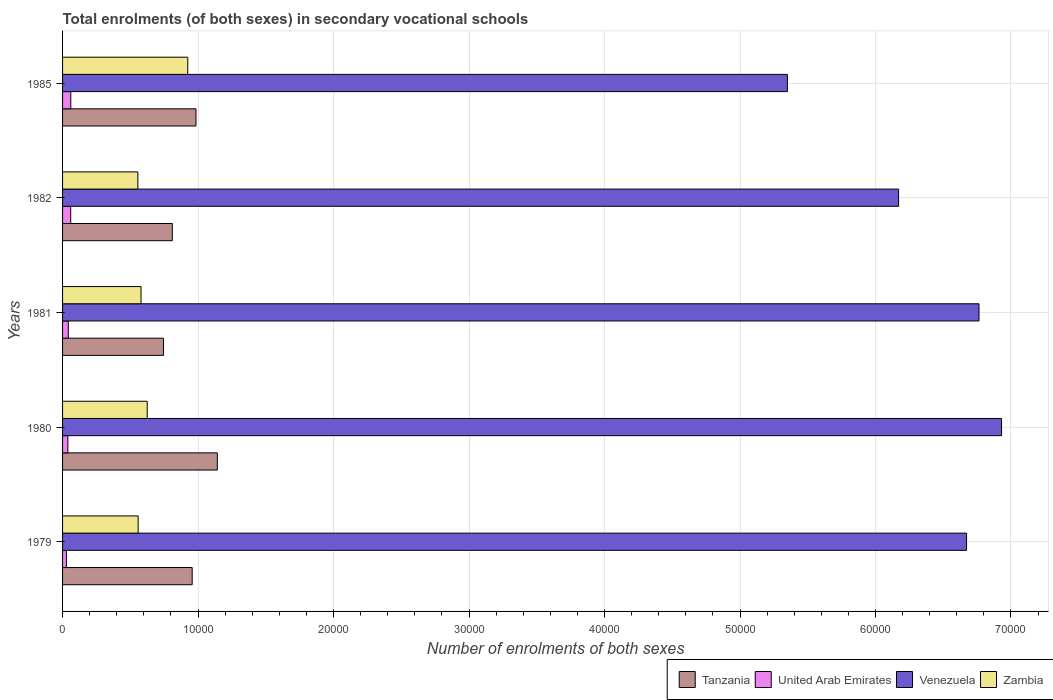How many different coloured bars are there?
Offer a very short reply. 4. How many groups of bars are there?
Make the answer very short. 5. Are the number of bars on each tick of the Y-axis equal?
Provide a short and direct response. Yes. How many bars are there on the 1st tick from the bottom?
Provide a short and direct response. 4. What is the label of the 3rd group of bars from the top?
Your response must be concise. 1981. In how many cases, is the number of bars for a given year not equal to the number of legend labels?
Keep it short and to the point. 0. What is the number of enrolments in secondary schools in Zambia in 1980?
Give a very brief answer. 6248. Across all years, what is the maximum number of enrolments in secondary schools in United Arab Emirates?
Provide a succinct answer. 607. Across all years, what is the minimum number of enrolments in secondary schools in United Arab Emirates?
Ensure brevity in your answer.  284. What is the total number of enrolments in secondary schools in Venezuela in the graph?
Ensure brevity in your answer.  3.19e+05. What is the difference between the number of enrolments in secondary schools in Tanzania in 1979 and that in 1981?
Keep it short and to the point. 2118. What is the difference between the number of enrolments in secondary schools in Zambia in 1981 and the number of enrolments in secondary schools in United Arab Emirates in 1985?
Provide a succinct answer. 5183. What is the average number of enrolments in secondary schools in Tanzania per year?
Keep it short and to the point. 9277.4. In the year 1981, what is the difference between the number of enrolments in secondary schools in Tanzania and number of enrolments in secondary schools in United Arab Emirates?
Your answer should be very brief. 7027. In how many years, is the number of enrolments in secondary schools in Zambia greater than 62000 ?
Offer a terse response. 0. What is the ratio of the number of enrolments in secondary schools in United Arab Emirates in 1980 to that in 1982?
Offer a very short reply. 0.65. Is the number of enrolments in secondary schools in United Arab Emirates in 1980 less than that in 1982?
Provide a short and direct response. Yes. Is the difference between the number of enrolments in secondary schools in Tanzania in 1980 and 1982 greater than the difference between the number of enrolments in secondary schools in United Arab Emirates in 1980 and 1982?
Offer a very short reply. Yes. What is the difference between the highest and the second highest number of enrolments in secondary schools in Venezuela?
Give a very brief answer. 1663. What is the difference between the highest and the lowest number of enrolments in secondary schools in Zambia?
Keep it short and to the point. 3684. What does the 1st bar from the top in 1979 represents?
Keep it short and to the point. Zambia. What does the 4th bar from the bottom in 1980 represents?
Keep it short and to the point. Zambia. What is the difference between two consecutive major ticks on the X-axis?
Your answer should be compact. 10000. Are the values on the major ticks of X-axis written in scientific E-notation?
Provide a succinct answer. No. Does the graph contain any zero values?
Keep it short and to the point. No. Where does the legend appear in the graph?
Provide a short and direct response. Bottom right. What is the title of the graph?
Provide a short and direct response. Total enrolments (of both sexes) in secondary vocational schools. Does "New Caledonia" appear as one of the legend labels in the graph?
Offer a very short reply. No. What is the label or title of the X-axis?
Your response must be concise. Number of enrolments of both sexes. What is the Number of enrolments of both sexes in Tanzania in 1979?
Keep it short and to the point. 9567. What is the Number of enrolments of both sexes of United Arab Emirates in 1979?
Ensure brevity in your answer.  284. What is the Number of enrolments of both sexes in Venezuela in 1979?
Ensure brevity in your answer.  6.67e+04. What is the Number of enrolments of both sexes of Zambia in 1979?
Provide a succinct answer. 5578. What is the Number of enrolments of both sexes in Tanzania in 1980?
Give a very brief answer. 1.14e+04. What is the Number of enrolments of both sexes of United Arab Emirates in 1980?
Keep it short and to the point. 392. What is the Number of enrolments of both sexes in Venezuela in 1980?
Provide a succinct answer. 6.93e+04. What is the Number of enrolments of both sexes in Zambia in 1980?
Your answer should be compact. 6248. What is the Number of enrolments of both sexes in Tanzania in 1981?
Keep it short and to the point. 7449. What is the Number of enrolments of both sexes in United Arab Emirates in 1981?
Your answer should be very brief. 422. What is the Number of enrolments of both sexes of Venezuela in 1981?
Your response must be concise. 6.76e+04. What is the Number of enrolments of both sexes of Zambia in 1981?
Your answer should be very brief. 5790. What is the Number of enrolments of both sexes in Tanzania in 1982?
Provide a succinct answer. 8101. What is the Number of enrolments of both sexes in United Arab Emirates in 1982?
Offer a very short reply. 602. What is the Number of enrolments of both sexes of Venezuela in 1982?
Your response must be concise. 6.17e+04. What is the Number of enrolments of both sexes in Zambia in 1982?
Your answer should be compact. 5557. What is the Number of enrolments of both sexes of Tanzania in 1985?
Your answer should be very brief. 9847. What is the Number of enrolments of both sexes in United Arab Emirates in 1985?
Provide a short and direct response. 607. What is the Number of enrolments of both sexes of Venezuela in 1985?
Ensure brevity in your answer.  5.35e+04. What is the Number of enrolments of both sexes of Zambia in 1985?
Provide a short and direct response. 9241. Across all years, what is the maximum Number of enrolments of both sexes in Tanzania?
Give a very brief answer. 1.14e+04. Across all years, what is the maximum Number of enrolments of both sexes of United Arab Emirates?
Give a very brief answer. 607. Across all years, what is the maximum Number of enrolments of both sexes in Venezuela?
Keep it short and to the point. 6.93e+04. Across all years, what is the maximum Number of enrolments of both sexes of Zambia?
Give a very brief answer. 9241. Across all years, what is the minimum Number of enrolments of both sexes of Tanzania?
Your response must be concise. 7449. Across all years, what is the minimum Number of enrolments of both sexes of United Arab Emirates?
Provide a short and direct response. 284. Across all years, what is the minimum Number of enrolments of both sexes of Venezuela?
Give a very brief answer. 5.35e+04. Across all years, what is the minimum Number of enrolments of both sexes in Zambia?
Ensure brevity in your answer.  5557. What is the total Number of enrolments of both sexes in Tanzania in the graph?
Give a very brief answer. 4.64e+04. What is the total Number of enrolments of both sexes in United Arab Emirates in the graph?
Offer a very short reply. 2307. What is the total Number of enrolments of both sexes of Venezuela in the graph?
Provide a succinct answer. 3.19e+05. What is the total Number of enrolments of both sexes in Zambia in the graph?
Offer a terse response. 3.24e+04. What is the difference between the Number of enrolments of both sexes of Tanzania in 1979 and that in 1980?
Ensure brevity in your answer.  -1856. What is the difference between the Number of enrolments of both sexes of United Arab Emirates in 1979 and that in 1980?
Your response must be concise. -108. What is the difference between the Number of enrolments of both sexes of Venezuela in 1979 and that in 1980?
Provide a short and direct response. -2582. What is the difference between the Number of enrolments of both sexes of Zambia in 1979 and that in 1980?
Ensure brevity in your answer.  -670. What is the difference between the Number of enrolments of both sexes in Tanzania in 1979 and that in 1981?
Your response must be concise. 2118. What is the difference between the Number of enrolments of both sexes of United Arab Emirates in 1979 and that in 1981?
Keep it short and to the point. -138. What is the difference between the Number of enrolments of both sexes of Venezuela in 1979 and that in 1981?
Ensure brevity in your answer.  -919. What is the difference between the Number of enrolments of both sexes of Zambia in 1979 and that in 1981?
Your answer should be compact. -212. What is the difference between the Number of enrolments of both sexes in Tanzania in 1979 and that in 1982?
Your response must be concise. 1466. What is the difference between the Number of enrolments of both sexes in United Arab Emirates in 1979 and that in 1982?
Provide a short and direct response. -318. What is the difference between the Number of enrolments of both sexes of Venezuela in 1979 and that in 1982?
Your answer should be compact. 5016. What is the difference between the Number of enrolments of both sexes in Tanzania in 1979 and that in 1985?
Offer a very short reply. -280. What is the difference between the Number of enrolments of both sexes in United Arab Emirates in 1979 and that in 1985?
Give a very brief answer. -323. What is the difference between the Number of enrolments of both sexes in Venezuela in 1979 and that in 1985?
Your response must be concise. 1.32e+04. What is the difference between the Number of enrolments of both sexes of Zambia in 1979 and that in 1985?
Provide a succinct answer. -3663. What is the difference between the Number of enrolments of both sexes in Tanzania in 1980 and that in 1981?
Offer a very short reply. 3974. What is the difference between the Number of enrolments of both sexes in United Arab Emirates in 1980 and that in 1981?
Provide a succinct answer. -30. What is the difference between the Number of enrolments of both sexes of Venezuela in 1980 and that in 1981?
Provide a succinct answer. 1663. What is the difference between the Number of enrolments of both sexes of Zambia in 1980 and that in 1981?
Offer a terse response. 458. What is the difference between the Number of enrolments of both sexes of Tanzania in 1980 and that in 1982?
Offer a very short reply. 3322. What is the difference between the Number of enrolments of both sexes of United Arab Emirates in 1980 and that in 1982?
Provide a succinct answer. -210. What is the difference between the Number of enrolments of both sexes of Venezuela in 1980 and that in 1982?
Keep it short and to the point. 7598. What is the difference between the Number of enrolments of both sexes in Zambia in 1980 and that in 1982?
Give a very brief answer. 691. What is the difference between the Number of enrolments of both sexes in Tanzania in 1980 and that in 1985?
Make the answer very short. 1576. What is the difference between the Number of enrolments of both sexes in United Arab Emirates in 1980 and that in 1985?
Your answer should be very brief. -215. What is the difference between the Number of enrolments of both sexes of Venezuela in 1980 and that in 1985?
Your answer should be compact. 1.58e+04. What is the difference between the Number of enrolments of both sexes in Zambia in 1980 and that in 1985?
Your answer should be compact. -2993. What is the difference between the Number of enrolments of both sexes of Tanzania in 1981 and that in 1982?
Your answer should be compact. -652. What is the difference between the Number of enrolments of both sexes of United Arab Emirates in 1981 and that in 1982?
Your answer should be compact. -180. What is the difference between the Number of enrolments of both sexes of Venezuela in 1981 and that in 1982?
Your answer should be compact. 5935. What is the difference between the Number of enrolments of both sexes in Zambia in 1981 and that in 1982?
Make the answer very short. 233. What is the difference between the Number of enrolments of both sexes of Tanzania in 1981 and that in 1985?
Provide a short and direct response. -2398. What is the difference between the Number of enrolments of both sexes of United Arab Emirates in 1981 and that in 1985?
Offer a terse response. -185. What is the difference between the Number of enrolments of both sexes of Venezuela in 1981 and that in 1985?
Ensure brevity in your answer.  1.41e+04. What is the difference between the Number of enrolments of both sexes of Zambia in 1981 and that in 1985?
Offer a terse response. -3451. What is the difference between the Number of enrolments of both sexes of Tanzania in 1982 and that in 1985?
Your answer should be very brief. -1746. What is the difference between the Number of enrolments of both sexes in United Arab Emirates in 1982 and that in 1985?
Give a very brief answer. -5. What is the difference between the Number of enrolments of both sexes of Venezuela in 1982 and that in 1985?
Keep it short and to the point. 8209. What is the difference between the Number of enrolments of both sexes of Zambia in 1982 and that in 1985?
Your answer should be very brief. -3684. What is the difference between the Number of enrolments of both sexes of Tanzania in 1979 and the Number of enrolments of both sexes of United Arab Emirates in 1980?
Keep it short and to the point. 9175. What is the difference between the Number of enrolments of both sexes of Tanzania in 1979 and the Number of enrolments of both sexes of Venezuela in 1980?
Offer a terse response. -5.97e+04. What is the difference between the Number of enrolments of both sexes in Tanzania in 1979 and the Number of enrolments of both sexes in Zambia in 1980?
Provide a succinct answer. 3319. What is the difference between the Number of enrolments of both sexes of United Arab Emirates in 1979 and the Number of enrolments of both sexes of Venezuela in 1980?
Your answer should be very brief. -6.90e+04. What is the difference between the Number of enrolments of both sexes of United Arab Emirates in 1979 and the Number of enrolments of both sexes of Zambia in 1980?
Your response must be concise. -5964. What is the difference between the Number of enrolments of both sexes in Venezuela in 1979 and the Number of enrolments of both sexes in Zambia in 1980?
Your answer should be very brief. 6.05e+04. What is the difference between the Number of enrolments of both sexes of Tanzania in 1979 and the Number of enrolments of both sexes of United Arab Emirates in 1981?
Your answer should be very brief. 9145. What is the difference between the Number of enrolments of both sexes in Tanzania in 1979 and the Number of enrolments of both sexes in Venezuela in 1981?
Ensure brevity in your answer.  -5.81e+04. What is the difference between the Number of enrolments of both sexes of Tanzania in 1979 and the Number of enrolments of both sexes of Zambia in 1981?
Your response must be concise. 3777. What is the difference between the Number of enrolments of both sexes of United Arab Emirates in 1979 and the Number of enrolments of both sexes of Venezuela in 1981?
Your response must be concise. -6.74e+04. What is the difference between the Number of enrolments of both sexes in United Arab Emirates in 1979 and the Number of enrolments of both sexes in Zambia in 1981?
Provide a short and direct response. -5506. What is the difference between the Number of enrolments of both sexes in Venezuela in 1979 and the Number of enrolments of both sexes in Zambia in 1981?
Offer a very short reply. 6.09e+04. What is the difference between the Number of enrolments of both sexes in Tanzania in 1979 and the Number of enrolments of both sexes in United Arab Emirates in 1982?
Your answer should be compact. 8965. What is the difference between the Number of enrolments of both sexes in Tanzania in 1979 and the Number of enrolments of both sexes in Venezuela in 1982?
Your response must be concise. -5.21e+04. What is the difference between the Number of enrolments of both sexes of Tanzania in 1979 and the Number of enrolments of both sexes of Zambia in 1982?
Make the answer very short. 4010. What is the difference between the Number of enrolments of both sexes in United Arab Emirates in 1979 and the Number of enrolments of both sexes in Venezuela in 1982?
Provide a short and direct response. -6.14e+04. What is the difference between the Number of enrolments of both sexes of United Arab Emirates in 1979 and the Number of enrolments of both sexes of Zambia in 1982?
Your answer should be very brief. -5273. What is the difference between the Number of enrolments of both sexes of Venezuela in 1979 and the Number of enrolments of both sexes of Zambia in 1982?
Your answer should be compact. 6.12e+04. What is the difference between the Number of enrolments of both sexes in Tanzania in 1979 and the Number of enrolments of both sexes in United Arab Emirates in 1985?
Your answer should be compact. 8960. What is the difference between the Number of enrolments of both sexes in Tanzania in 1979 and the Number of enrolments of both sexes in Venezuela in 1985?
Ensure brevity in your answer.  -4.39e+04. What is the difference between the Number of enrolments of both sexes in Tanzania in 1979 and the Number of enrolments of both sexes in Zambia in 1985?
Offer a very short reply. 326. What is the difference between the Number of enrolments of both sexes of United Arab Emirates in 1979 and the Number of enrolments of both sexes of Venezuela in 1985?
Provide a short and direct response. -5.32e+04. What is the difference between the Number of enrolments of both sexes in United Arab Emirates in 1979 and the Number of enrolments of both sexes in Zambia in 1985?
Ensure brevity in your answer.  -8957. What is the difference between the Number of enrolments of both sexes of Venezuela in 1979 and the Number of enrolments of both sexes of Zambia in 1985?
Your answer should be very brief. 5.75e+04. What is the difference between the Number of enrolments of both sexes in Tanzania in 1980 and the Number of enrolments of both sexes in United Arab Emirates in 1981?
Your answer should be compact. 1.10e+04. What is the difference between the Number of enrolments of both sexes of Tanzania in 1980 and the Number of enrolments of both sexes of Venezuela in 1981?
Your answer should be very brief. -5.62e+04. What is the difference between the Number of enrolments of both sexes in Tanzania in 1980 and the Number of enrolments of both sexes in Zambia in 1981?
Provide a succinct answer. 5633. What is the difference between the Number of enrolments of both sexes of United Arab Emirates in 1980 and the Number of enrolments of both sexes of Venezuela in 1981?
Your answer should be very brief. -6.72e+04. What is the difference between the Number of enrolments of both sexes in United Arab Emirates in 1980 and the Number of enrolments of both sexes in Zambia in 1981?
Offer a very short reply. -5398. What is the difference between the Number of enrolments of both sexes of Venezuela in 1980 and the Number of enrolments of both sexes of Zambia in 1981?
Your answer should be compact. 6.35e+04. What is the difference between the Number of enrolments of both sexes of Tanzania in 1980 and the Number of enrolments of both sexes of United Arab Emirates in 1982?
Offer a very short reply. 1.08e+04. What is the difference between the Number of enrolments of both sexes of Tanzania in 1980 and the Number of enrolments of both sexes of Venezuela in 1982?
Offer a very short reply. -5.03e+04. What is the difference between the Number of enrolments of both sexes in Tanzania in 1980 and the Number of enrolments of both sexes in Zambia in 1982?
Keep it short and to the point. 5866. What is the difference between the Number of enrolments of both sexes of United Arab Emirates in 1980 and the Number of enrolments of both sexes of Venezuela in 1982?
Keep it short and to the point. -6.13e+04. What is the difference between the Number of enrolments of both sexes in United Arab Emirates in 1980 and the Number of enrolments of both sexes in Zambia in 1982?
Offer a very short reply. -5165. What is the difference between the Number of enrolments of both sexes of Venezuela in 1980 and the Number of enrolments of both sexes of Zambia in 1982?
Make the answer very short. 6.37e+04. What is the difference between the Number of enrolments of both sexes in Tanzania in 1980 and the Number of enrolments of both sexes in United Arab Emirates in 1985?
Provide a succinct answer. 1.08e+04. What is the difference between the Number of enrolments of both sexes of Tanzania in 1980 and the Number of enrolments of both sexes of Venezuela in 1985?
Your response must be concise. -4.21e+04. What is the difference between the Number of enrolments of both sexes in Tanzania in 1980 and the Number of enrolments of both sexes in Zambia in 1985?
Your answer should be compact. 2182. What is the difference between the Number of enrolments of both sexes of United Arab Emirates in 1980 and the Number of enrolments of both sexes of Venezuela in 1985?
Ensure brevity in your answer.  -5.31e+04. What is the difference between the Number of enrolments of both sexes in United Arab Emirates in 1980 and the Number of enrolments of both sexes in Zambia in 1985?
Offer a very short reply. -8849. What is the difference between the Number of enrolments of both sexes in Venezuela in 1980 and the Number of enrolments of both sexes in Zambia in 1985?
Provide a short and direct response. 6.01e+04. What is the difference between the Number of enrolments of both sexes of Tanzania in 1981 and the Number of enrolments of both sexes of United Arab Emirates in 1982?
Your answer should be compact. 6847. What is the difference between the Number of enrolments of both sexes in Tanzania in 1981 and the Number of enrolments of both sexes in Venezuela in 1982?
Provide a succinct answer. -5.43e+04. What is the difference between the Number of enrolments of both sexes of Tanzania in 1981 and the Number of enrolments of both sexes of Zambia in 1982?
Provide a short and direct response. 1892. What is the difference between the Number of enrolments of both sexes of United Arab Emirates in 1981 and the Number of enrolments of both sexes of Venezuela in 1982?
Your response must be concise. -6.13e+04. What is the difference between the Number of enrolments of both sexes of United Arab Emirates in 1981 and the Number of enrolments of both sexes of Zambia in 1982?
Your response must be concise. -5135. What is the difference between the Number of enrolments of both sexes in Venezuela in 1981 and the Number of enrolments of both sexes in Zambia in 1982?
Your answer should be very brief. 6.21e+04. What is the difference between the Number of enrolments of both sexes of Tanzania in 1981 and the Number of enrolments of both sexes of United Arab Emirates in 1985?
Offer a very short reply. 6842. What is the difference between the Number of enrolments of both sexes of Tanzania in 1981 and the Number of enrolments of both sexes of Venezuela in 1985?
Provide a short and direct response. -4.60e+04. What is the difference between the Number of enrolments of both sexes of Tanzania in 1981 and the Number of enrolments of both sexes of Zambia in 1985?
Give a very brief answer. -1792. What is the difference between the Number of enrolments of both sexes in United Arab Emirates in 1981 and the Number of enrolments of both sexes in Venezuela in 1985?
Provide a short and direct response. -5.31e+04. What is the difference between the Number of enrolments of both sexes in United Arab Emirates in 1981 and the Number of enrolments of both sexes in Zambia in 1985?
Your answer should be very brief. -8819. What is the difference between the Number of enrolments of both sexes of Venezuela in 1981 and the Number of enrolments of both sexes of Zambia in 1985?
Ensure brevity in your answer.  5.84e+04. What is the difference between the Number of enrolments of both sexes of Tanzania in 1982 and the Number of enrolments of both sexes of United Arab Emirates in 1985?
Ensure brevity in your answer.  7494. What is the difference between the Number of enrolments of both sexes of Tanzania in 1982 and the Number of enrolments of both sexes of Venezuela in 1985?
Make the answer very short. -4.54e+04. What is the difference between the Number of enrolments of both sexes in Tanzania in 1982 and the Number of enrolments of both sexes in Zambia in 1985?
Provide a succinct answer. -1140. What is the difference between the Number of enrolments of both sexes in United Arab Emirates in 1982 and the Number of enrolments of both sexes in Venezuela in 1985?
Make the answer very short. -5.29e+04. What is the difference between the Number of enrolments of both sexes in United Arab Emirates in 1982 and the Number of enrolments of both sexes in Zambia in 1985?
Your response must be concise. -8639. What is the difference between the Number of enrolments of both sexes of Venezuela in 1982 and the Number of enrolments of both sexes of Zambia in 1985?
Offer a terse response. 5.25e+04. What is the average Number of enrolments of both sexes in Tanzania per year?
Your response must be concise. 9277.4. What is the average Number of enrolments of both sexes in United Arab Emirates per year?
Your response must be concise. 461.4. What is the average Number of enrolments of both sexes of Venezuela per year?
Your response must be concise. 6.38e+04. What is the average Number of enrolments of both sexes of Zambia per year?
Your answer should be compact. 6482.8. In the year 1979, what is the difference between the Number of enrolments of both sexes in Tanzania and Number of enrolments of both sexes in United Arab Emirates?
Make the answer very short. 9283. In the year 1979, what is the difference between the Number of enrolments of both sexes in Tanzania and Number of enrolments of both sexes in Venezuela?
Keep it short and to the point. -5.72e+04. In the year 1979, what is the difference between the Number of enrolments of both sexes of Tanzania and Number of enrolments of both sexes of Zambia?
Make the answer very short. 3989. In the year 1979, what is the difference between the Number of enrolments of both sexes of United Arab Emirates and Number of enrolments of both sexes of Venezuela?
Make the answer very short. -6.64e+04. In the year 1979, what is the difference between the Number of enrolments of both sexes of United Arab Emirates and Number of enrolments of both sexes of Zambia?
Provide a succinct answer. -5294. In the year 1979, what is the difference between the Number of enrolments of both sexes of Venezuela and Number of enrolments of both sexes of Zambia?
Your answer should be very brief. 6.11e+04. In the year 1980, what is the difference between the Number of enrolments of both sexes in Tanzania and Number of enrolments of both sexes in United Arab Emirates?
Ensure brevity in your answer.  1.10e+04. In the year 1980, what is the difference between the Number of enrolments of both sexes in Tanzania and Number of enrolments of both sexes in Venezuela?
Your answer should be very brief. -5.79e+04. In the year 1980, what is the difference between the Number of enrolments of both sexes in Tanzania and Number of enrolments of both sexes in Zambia?
Offer a terse response. 5175. In the year 1980, what is the difference between the Number of enrolments of both sexes in United Arab Emirates and Number of enrolments of both sexes in Venezuela?
Ensure brevity in your answer.  -6.89e+04. In the year 1980, what is the difference between the Number of enrolments of both sexes of United Arab Emirates and Number of enrolments of both sexes of Zambia?
Your response must be concise. -5856. In the year 1980, what is the difference between the Number of enrolments of both sexes in Venezuela and Number of enrolments of both sexes in Zambia?
Keep it short and to the point. 6.31e+04. In the year 1981, what is the difference between the Number of enrolments of both sexes of Tanzania and Number of enrolments of both sexes of United Arab Emirates?
Give a very brief answer. 7027. In the year 1981, what is the difference between the Number of enrolments of both sexes of Tanzania and Number of enrolments of both sexes of Venezuela?
Make the answer very short. -6.02e+04. In the year 1981, what is the difference between the Number of enrolments of both sexes in Tanzania and Number of enrolments of both sexes in Zambia?
Your answer should be compact. 1659. In the year 1981, what is the difference between the Number of enrolments of both sexes in United Arab Emirates and Number of enrolments of both sexes in Venezuela?
Make the answer very short. -6.72e+04. In the year 1981, what is the difference between the Number of enrolments of both sexes of United Arab Emirates and Number of enrolments of both sexes of Zambia?
Your response must be concise. -5368. In the year 1981, what is the difference between the Number of enrolments of both sexes of Venezuela and Number of enrolments of both sexes of Zambia?
Ensure brevity in your answer.  6.19e+04. In the year 1982, what is the difference between the Number of enrolments of both sexes in Tanzania and Number of enrolments of both sexes in United Arab Emirates?
Provide a short and direct response. 7499. In the year 1982, what is the difference between the Number of enrolments of both sexes of Tanzania and Number of enrolments of both sexes of Venezuela?
Give a very brief answer. -5.36e+04. In the year 1982, what is the difference between the Number of enrolments of both sexes in Tanzania and Number of enrolments of both sexes in Zambia?
Give a very brief answer. 2544. In the year 1982, what is the difference between the Number of enrolments of both sexes in United Arab Emirates and Number of enrolments of both sexes in Venezuela?
Your answer should be very brief. -6.11e+04. In the year 1982, what is the difference between the Number of enrolments of both sexes of United Arab Emirates and Number of enrolments of both sexes of Zambia?
Ensure brevity in your answer.  -4955. In the year 1982, what is the difference between the Number of enrolments of both sexes of Venezuela and Number of enrolments of both sexes of Zambia?
Keep it short and to the point. 5.61e+04. In the year 1985, what is the difference between the Number of enrolments of both sexes in Tanzania and Number of enrolments of both sexes in United Arab Emirates?
Give a very brief answer. 9240. In the year 1985, what is the difference between the Number of enrolments of both sexes in Tanzania and Number of enrolments of both sexes in Venezuela?
Your response must be concise. -4.36e+04. In the year 1985, what is the difference between the Number of enrolments of both sexes in Tanzania and Number of enrolments of both sexes in Zambia?
Offer a very short reply. 606. In the year 1985, what is the difference between the Number of enrolments of both sexes in United Arab Emirates and Number of enrolments of both sexes in Venezuela?
Make the answer very short. -5.29e+04. In the year 1985, what is the difference between the Number of enrolments of both sexes of United Arab Emirates and Number of enrolments of both sexes of Zambia?
Give a very brief answer. -8634. In the year 1985, what is the difference between the Number of enrolments of both sexes in Venezuela and Number of enrolments of both sexes in Zambia?
Your answer should be very brief. 4.43e+04. What is the ratio of the Number of enrolments of both sexes in Tanzania in 1979 to that in 1980?
Offer a very short reply. 0.84. What is the ratio of the Number of enrolments of both sexes in United Arab Emirates in 1979 to that in 1980?
Your answer should be compact. 0.72. What is the ratio of the Number of enrolments of both sexes of Venezuela in 1979 to that in 1980?
Your answer should be compact. 0.96. What is the ratio of the Number of enrolments of both sexes of Zambia in 1979 to that in 1980?
Give a very brief answer. 0.89. What is the ratio of the Number of enrolments of both sexes of Tanzania in 1979 to that in 1981?
Your response must be concise. 1.28. What is the ratio of the Number of enrolments of both sexes of United Arab Emirates in 1979 to that in 1981?
Your response must be concise. 0.67. What is the ratio of the Number of enrolments of both sexes of Venezuela in 1979 to that in 1981?
Provide a succinct answer. 0.99. What is the ratio of the Number of enrolments of both sexes of Zambia in 1979 to that in 1981?
Provide a succinct answer. 0.96. What is the ratio of the Number of enrolments of both sexes of Tanzania in 1979 to that in 1982?
Ensure brevity in your answer.  1.18. What is the ratio of the Number of enrolments of both sexes in United Arab Emirates in 1979 to that in 1982?
Offer a very short reply. 0.47. What is the ratio of the Number of enrolments of both sexes in Venezuela in 1979 to that in 1982?
Provide a short and direct response. 1.08. What is the ratio of the Number of enrolments of both sexes in Tanzania in 1979 to that in 1985?
Ensure brevity in your answer.  0.97. What is the ratio of the Number of enrolments of both sexes of United Arab Emirates in 1979 to that in 1985?
Your response must be concise. 0.47. What is the ratio of the Number of enrolments of both sexes of Venezuela in 1979 to that in 1985?
Provide a short and direct response. 1.25. What is the ratio of the Number of enrolments of both sexes in Zambia in 1979 to that in 1985?
Your response must be concise. 0.6. What is the ratio of the Number of enrolments of both sexes of Tanzania in 1980 to that in 1981?
Keep it short and to the point. 1.53. What is the ratio of the Number of enrolments of both sexes of United Arab Emirates in 1980 to that in 1981?
Keep it short and to the point. 0.93. What is the ratio of the Number of enrolments of both sexes of Venezuela in 1980 to that in 1981?
Offer a terse response. 1.02. What is the ratio of the Number of enrolments of both sexes of Zambia in 1980 to that in 1981?
Your response must be concise. 1.08. What is the ratio of the Number of enrolments of both sexes of Tanzania in 1980 to that in 1982?
Your answer should be compact. 1.41. What is the ratio of the Number of enrolments of both sexes of United Arab Emirates in 1980 to that in 1982?
Offer a very short reply. 0.65. What is the ratio of the Number of enrolments of both sexes in Venezuela in 1980 to that in 1982?
Keep it short and to the point. 1.12. What is the ratio of the Number of enrolments of both sexes in Zambia in 1980 to that in 1982?
Offer a terse response. 1.12. What is the ratio of the Number of enrolments of both sexes in Tanzania in 1980 to that in 1985?
Ensure brevity in your answer.  1.16. What is the ratio of the Number of enrolments of both sexes in United Arab Emirates in 1980 to that in 1985?
Offer a terse response. 0.65. What is the ratio of the Number of enrolments of both sexes of Venezuela in 1980 to that in 1985?
Make the answer very short. 1.3. What is the ratio of the Number of enrolments of both sexes in Zambia in 1980 to that in 1985?
Offer a very short reply. 0.68. What is the ratio of the Number of enrolments of both sexes in Tanzania in 1981 to that in 1982?
Your answer should be very brief. 0.92. What is the ratio of the Number of enrolments of both sexes in United Arab Emirates in 1981 to that in 1982?
Give a very brief answer. 0.7. What is the ratio of the Number of enrolments of both sexes of Venezuela in 1981 to that in 1982?
Offer a very short reply. 1.1. What is the ratio of the Number of enrolments of both sexes of Zambia in 1981 to that in 1982?
Your answer should be very brief. 1.04. What is the ratio of the Number of enrolments of both sexes of Tanzania in 1981 to that in 1985?
Keep it short and to the point. 0.76. What is the ratio of the Number of enrolments of both sexes in United Arab Emirates in 1981 to that in 1985?
Give a very brief answer. 0.7. What is the ratio of the Number of enrolments of both sexes of Venezuela in 1981 to that in 1985?
Ensure brevity in your answer.  1.26. What is the ratio of the Number of enrolments of both sexes in Zambia in 1981 to that in 1985?
Your response must be concise. 0.63. What is the ratio of the Number of enrolments of both sexes in Tanzania in 1982 to that in 1985?
Offer a very short reply. 0.82. What is the ratio of the Number of enrolments of both sexes of Venezuela in 1982 to that in 1985?
Your answer should be compact. 1.15. What is the ratio of the Number of enrolments of both sexes in Zambia in 1982 to that in 1985?
Your answer should be compact. 0.6. What is the difference between the highest and the second highest Number of enrolments of both sexes in Tanzania?
Offer a terse response. 1576. What is the difference between the highest and the second highest Number of enrolments of both sexes in United Arab Emirates?
Provide a succinct answer. 5. What is the difference between the highest and the second highest Number of enrolments of both sexes of Venezuela?
Offer a very short reply. 1663. What is the difference between the highest and the second highest Number of enrolments of both sexes of Zambia?
Make the answer very short. 2993. What is the difference between the highest and the lowest Number of enrolments of both sexes in Tanzania?
Provide a short and direct response. 3974. What is the difference between the highest and the lowest Number of enrolments of both sexes of United Arab Emirates?
Offer a terse response. 323. What is the difference between the highest and the lowest Number of enrolments of both sexes of Venezuela?
Keep it short and to the point. 1.58e+04. What is the difference between the highest and the lowest Number of enrolments of both sexes of Zambia?
Keep it short and to the point. 3684. 